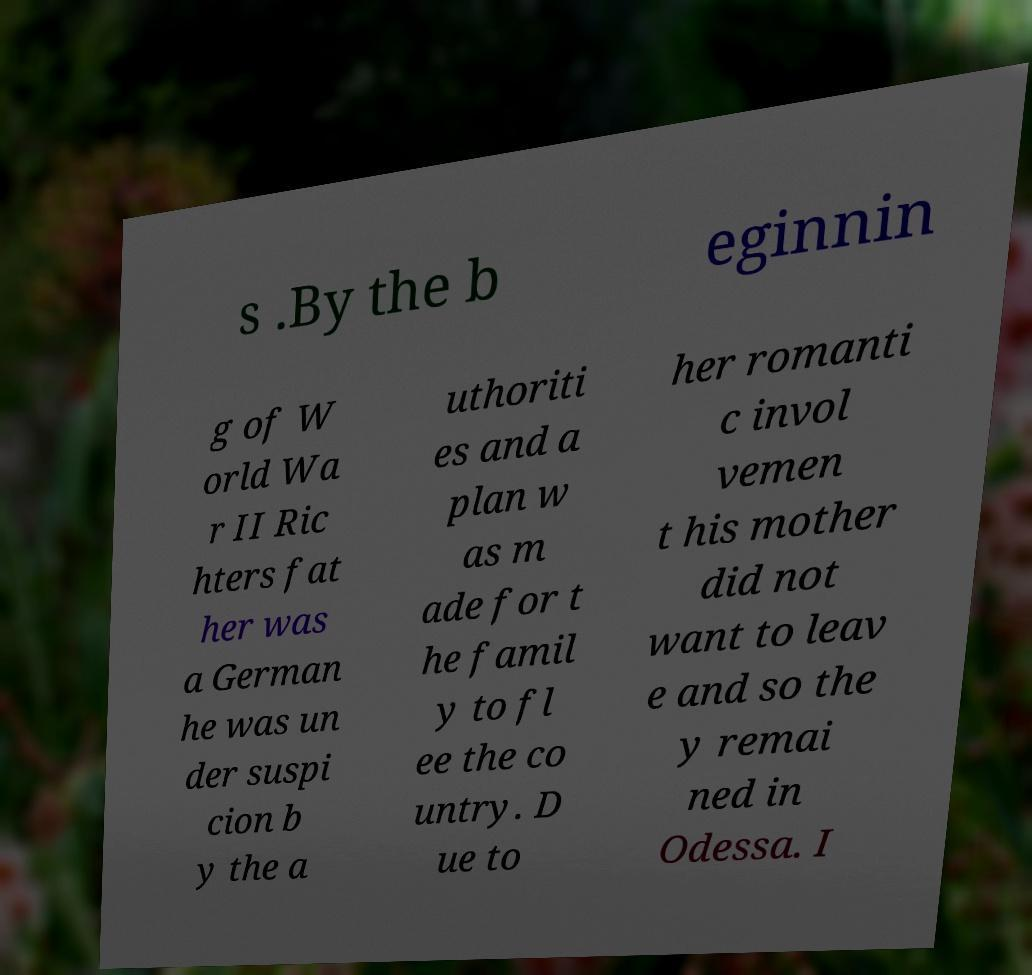Can you accurately transcribe the text from the provided image for me? s .By the b eginnin g of W orld Wa r II Ric hters fat her was a German he was un der suspi cion b y the a uthoriti es and a plan w as m ade for t he famil y to fl ee the co untry. D ue to her romanti c invol vemen t his mother did not want to leav e and so the y remai ned in Odessa. I 